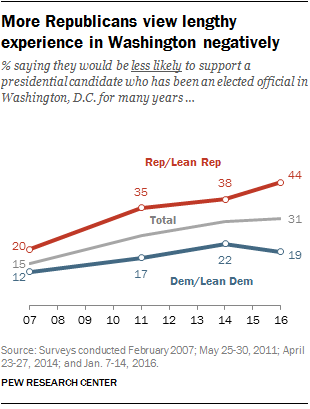Point out several critical features in this image. The color of the graph with the highest value of 44 is red. The median value of the red graph is 36.5. 